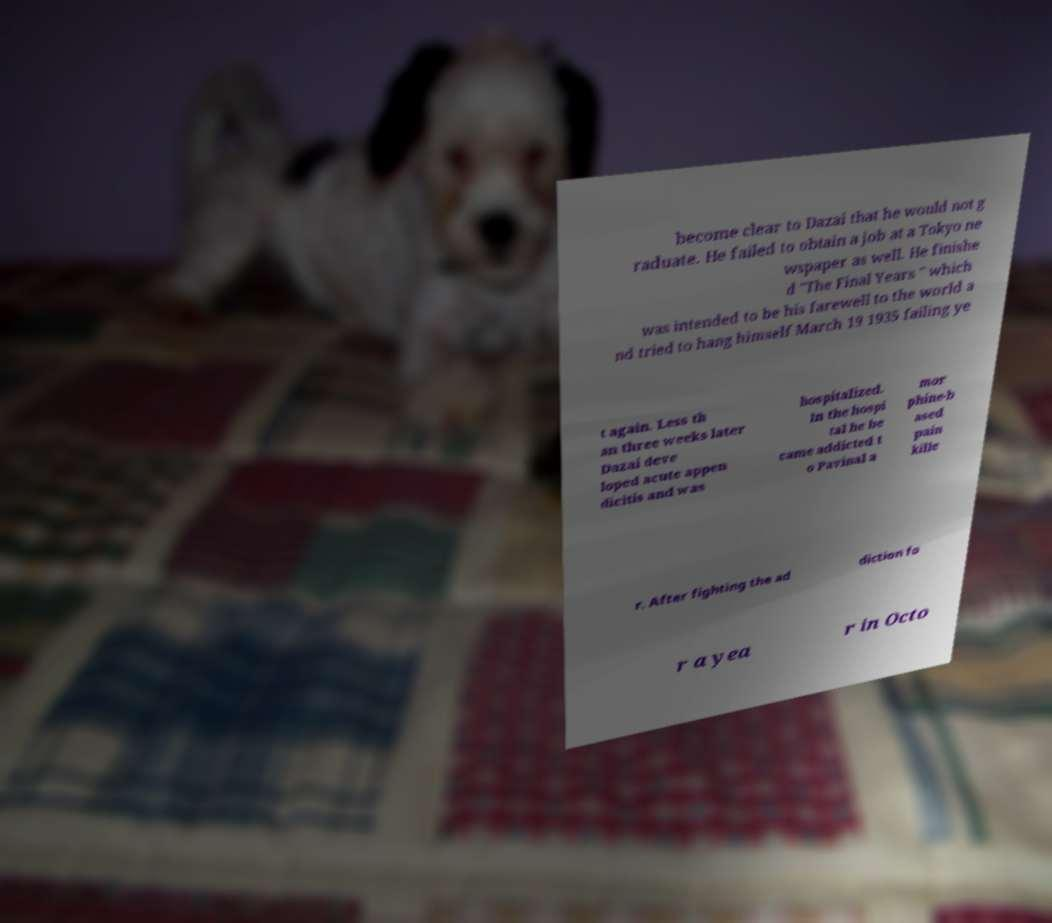For documentation purposes, I need the text within this image transcribed. Could you provide that? become clear to Dazai that he would not g raduate. He failed to obtain a job at a Tokyo ne wspaper as well. He finishe d "The Final Years " which was intended to be his farewell to the world a nd tried to hang himself March 19 1935 failing ye t again. Less th an three weeks later Dazai deve loped acute appen dicitis and was hospitalized. In the hospi tal he be came addicted t o Pavinal a mor phine-b ased pain kille r. After fighting the ad diction fo r a yea r in Octo 